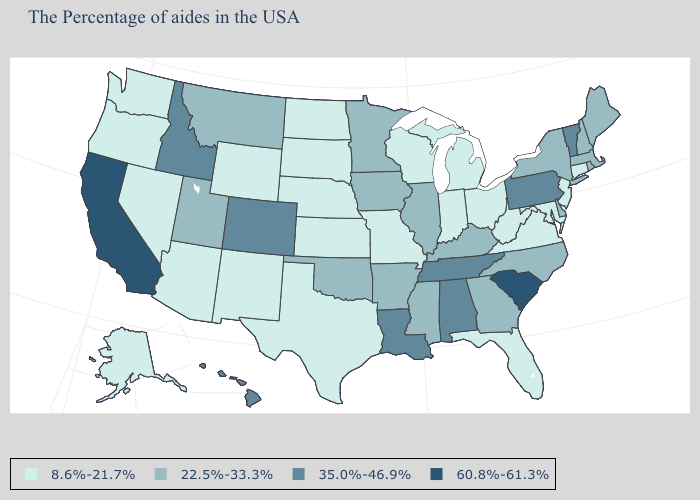Among the states that border California , which have the lowest value?
Quick response, please. Arizona, Nevada, Oregon. Name the states that have a value in the range 60.8%-61.3%?
Give a very brief answer. South Carolina, California. How many symbols are there in the legend?
Answer briefly. 4. Which states have the lowest value in the MidWest?
Be succinct. Ohio, Michigan, Indiana, Wisconsin, Missouri, Kansas, Nebraska, South Dakota, North Dakota. Does California have the lowest value in the USA?
Quick response, please. No. Among the states that border New Hampshire , which have the lowest value?
Give a very brief answer. Maine, Massachusetts. Does New Hampshire have the lowest value in the USA?
Quick response, please. No. Name the states that have a value in the range 8.6%-21.7%?
Answer briefly. Connecticut, New Jersey, Maryland, Virginia, West Virginia, Ohio, Florida, Michigan, Indiana, Wisconsin, Missouri, Kansas, Nebraska, Texas, South Dakota, North Dakota, Wyoming, New Mexico, Arizona, Nevada, Washington, Oregon, Alaska. Name the states that have a value in the range 60.8%-61.3%?
Give a very brief answer. South Carolina, California. Among the states that border South Carolina , which have the lowest value?
Give a very brief answer. North Carolina, Georgia. Name the states that have a value in the range 60.8%-61.3%?
Concise answer only. South Carolina, California. Which states have the lowest value in the South?
Answer briefly. Maryland, Virginia, West Virginia, Florida, Texas. Name the states that have a value in the range 35.0%-46.9%?
Write a very short answer. Vermont, Pennsylvania, Alabama, Tennessee, Louisiana, Colorado, Idaho, Hawaii. Which states have the lowest value in the South?
Short answer required. Maryland, Virginia, West Virginia, Florida, Texas. Name the states that have a value in the range 8.6%-21.7%?
Quick response, please. Connecticut, New Jersey, Maryland, Virginia, West Virginia, Ohio, Florida, Michigan, Indiana, Wisconsin, Missouri, Kansas, Nebraska, Texas, South Dakota, North Dakota, Wyoming, New Mexico, Arizona, Nevada, Washington, Oregon, Alaska. 